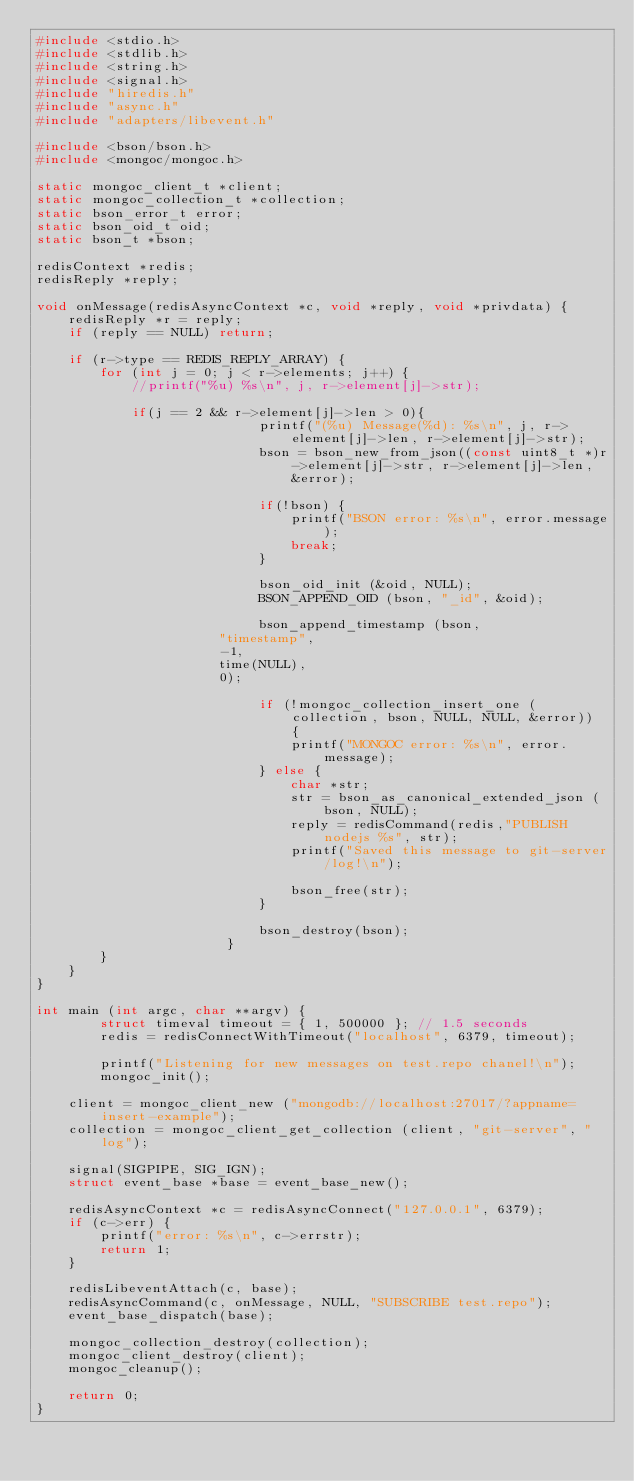Convert code to text. <code><loc_0><loc_0><loc_500><loc_500><_C_>#include <stdio.h>
#include <stdlib.h>
#include <string.h>
#include <signal.h>
#include "hiredis.h"
#include "async.h"
#include "adapters/libevent.h"

#include <bson/bson.h>
#include <mongoc/mongoc.h>

static mongoc_client_t *client;
static mongoc_collection_t *collection;
static bson_error_t error;
static bson_oid_t oid;
static bson_t *bson;

redisContext *redis;
redisReply *reply;	

void onMessage(redisAsyncContext *c, void *reply, void *privdata) {
    redisReply *r = reply;
    if (reply == NULL) return;

    if (r->type == REDIS_REPLY_ARRAY) {
        for (int j = 0; j < r->elements; j++) {
            //printf("%u) %s\n", j, r->element[j]->str);
            
            if(j == 2 && r->element[j]->len > 0){
							printf("(%u) Message(%d): %s\n", j, r->element[j]->len, r->element[j]->str);
							bson = bson_new_from_json((const uint8_t *)r->element[j]->str, r->element[j]->len, &error);
														
							if(!bson) {
								printf("BSON error: %s\n", error.message);
								break;
							}
							
							bson_oid_init (&oid, NULL);
							BSON_APPEND_OID (bson, "_id", &oid);
							
							bson_append_timestamp (bson,
                       "timestamp",
                       -1,
                       time(NULL),
                       0);
							
							if (!mongoc_collection_insert_one (collection, bson, NULL, NULL, &error)) {
								printf("MONGOC error: %s\n", error.message);
							} else {
								char *str;
								str = bson_as_canonical_extended_json (bson, NULL);
								reply = redisCommand(redis,"PUBLISH nodejs %s", str);
								printf("Saved this message to git-server/log!\n");
								
								bson_free(str);
							}

							bson_destroy(bson);
						}
        }
    }
}

int main (int argc, char **argv) {
		struct timeval timeout = { 1, 500000 }; // 1.5 seconds
		redis = redisConnectWithTimeout("localhost", 6379, timeout);
		
		printf("Listening for new messages on test.repo chanel!\n");
		mongoc_init();

    client = mongoc_client_new ("mongodb://localhost:27017/?appname=insert-example");
    collection = mongoc_client_get_collection (client, "git-server", "log");
    
    signal(SIGPIPE, SIG_IGN);
    struct event_base *base = event_base_new();

    redisAsyncContext *c = redisAsyncConnect("127.0.0.1", 6379);
    if (c->err) {
        printf("error: %s\n", c->errstr);
        return 1;
    }

    redisLibeventAttach(c, base);
    redisAsyncCommand(c, onMessage, NULL, "SUBSCRIBE test.repo");
    event_base_dispatch(base);
    
    mongoc_collection_destroy(collection);
    mongoc_client_destroy(client);
    mongoc_cleanup();
    
    return 0;
}
</code> 